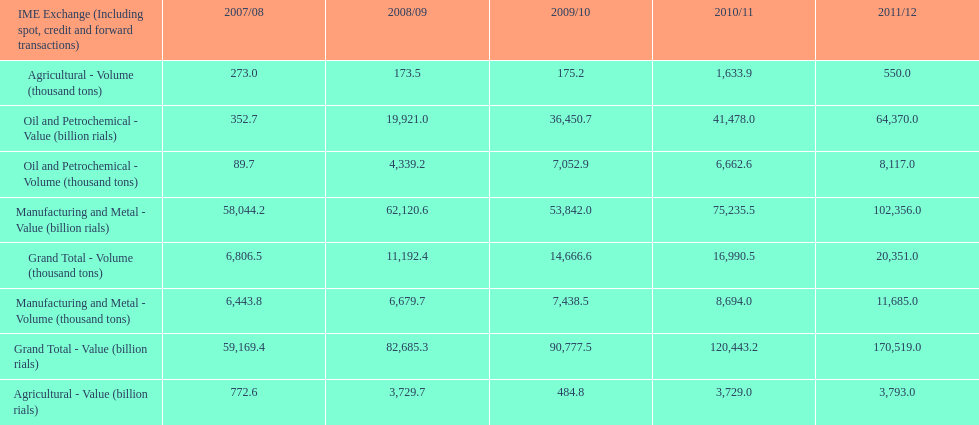What is the total agricultural value in 2008/09? 3,729.7. 